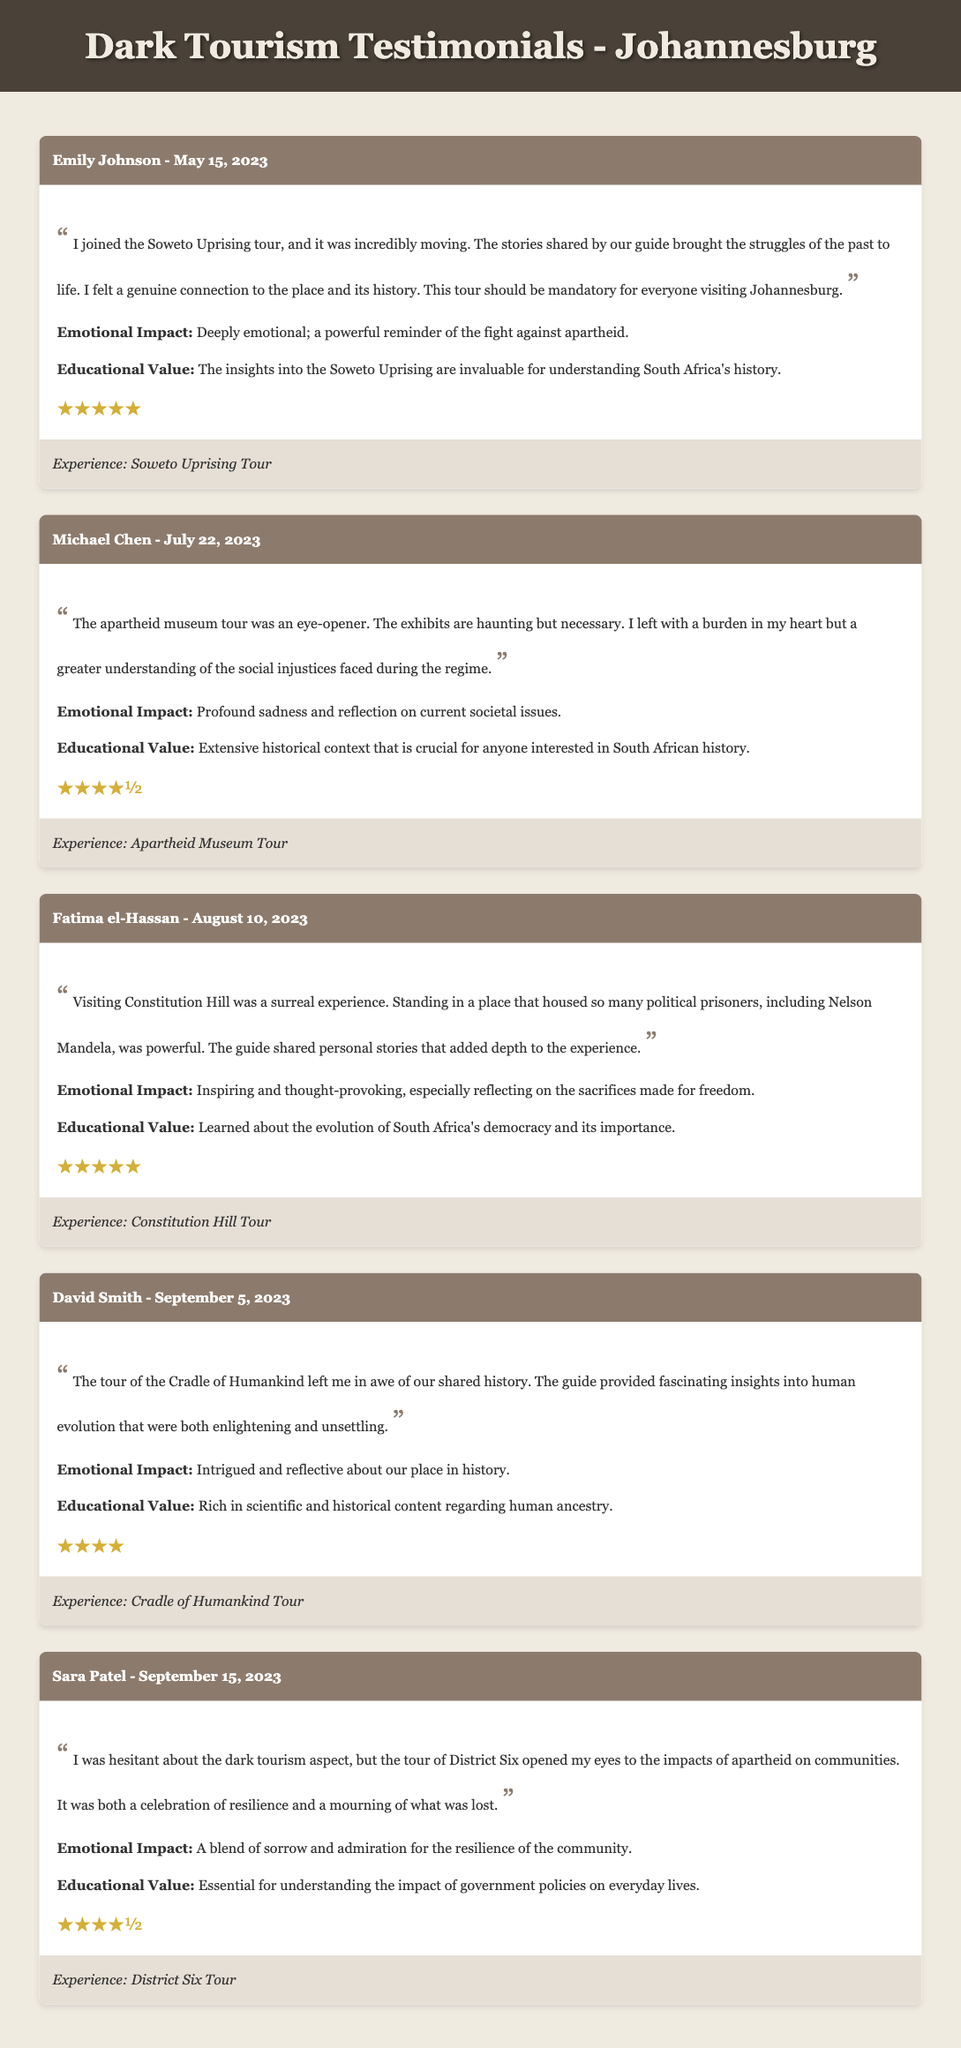What is the name of the first testimonial writer? The first testimonial is written by Emily Johnson.
Answer: Emily Johnson When did Michael Chen take his tour? Michael Chen took his tour on July 22, 2023.
Answer: July 22, 2023 What experience did Fatima el-Hassan share about? Fatima el-Hassan's testimonial is about the Constitution Hill Tour.
Answer: Constitution Hill Tour How many stars did David Smith rate his experience? David Smith rated his experience with four stars.
Answer: ★★★★ What emotional impact did the District Six Tour have on Sara Patel? The emotional impact was a blend of sorrow and admiration.
Answer: A blend of sorrow and admiration What is the educational value mentioned by Emily Johnson? The educational value is about understanding South Africa's history.
Answer: Understanding South Africa's history Which tourist mentioned feelings of profound sadness? Michael Chen mentioned feelings of profound sadness.
Answer: Michael Chen How many testimonials received five-star ratings? Three testimonials received five-star ratings.
Answer: Three 